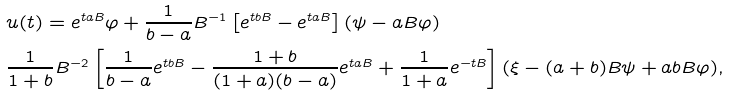Convert formula to latex. <formula><loc_0><loc_0><loc_500><loc_500>& u ( t ) = e ^ { t a B } \varphi + \frac { 1 } { b - a } B ^ { - 1 } \left [ e ^ { t b B } - e ^ { t a B } \right ] ( \psi - a B \varphi ) \\ & \frac { 1 } { 1 + b } B ^ { - 2 } \left [ \frac { 1 } { b - a } e ^ { t b B } - \frac { 1 + b } { ( 1 + a ) ( b - a ) } e ^ { t a B } + \frac { 1 } { 1 + a } e ^ { - t B } \right ] ( \xi - ( a + b ) B \psi + a b B \varphi ) ,</formula> 